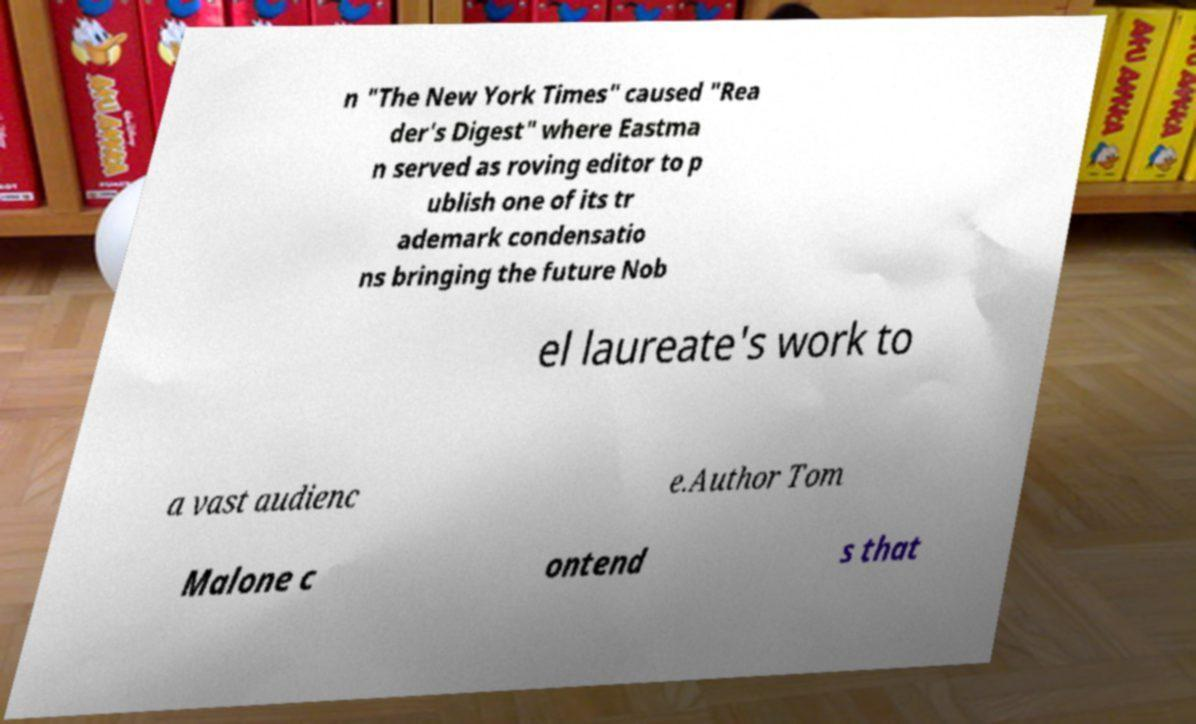Please read and relay the text visible in this image. What does it say? n "The New York Times" caused "Rea der's Digest" where Eastma n served as roving editor to p ublish one of its tr ademark condensatio ns bringing the future Nob el laureate's work to a vast audienc e.Author Tom Malone c ontend s that 